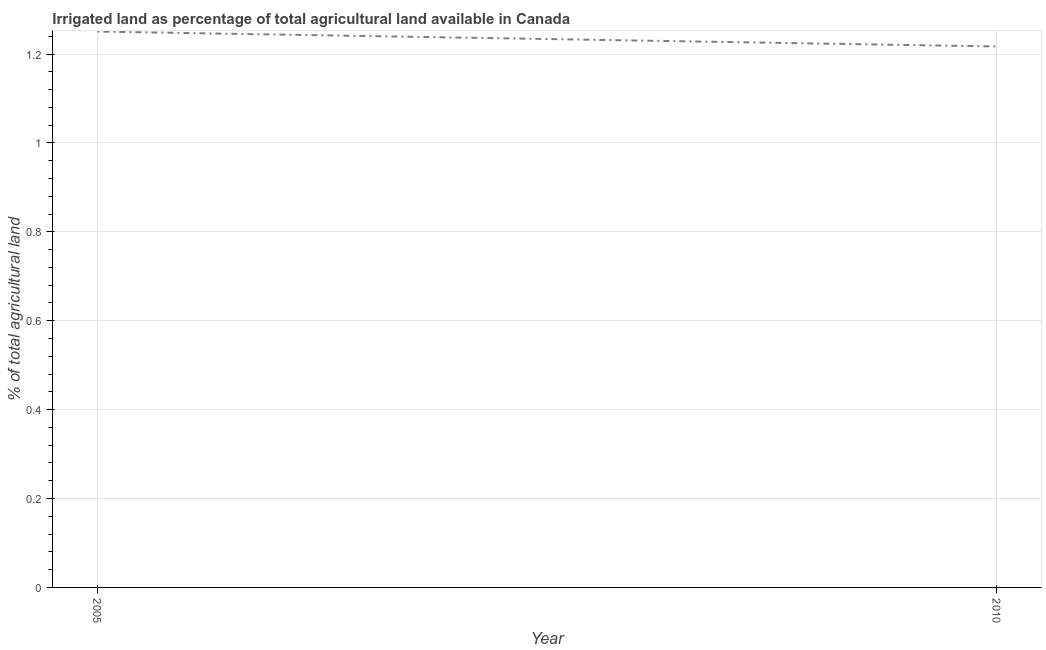What is the percentage of agricultural irrigated land in 2010?
Provide a short and direct response. 1.22. Across all years, what is the maximum percentage of agricultural irrigated land?
Make the answer very short. 1.25. Across all years, what is the minimum percentage of agricultural irrigated land?
Your response must be concise. 1.22. In which year was the percentage of agricultural irrigated land maximum?
Make the answer very short. 2005. In which year was the percentage of agricultural irrigated land minimum?
Keep it short and to the point. 2010. What is the sum of the percentage of agricultural irrigated land?
Give a very brief answer. 2.47. What is the difference between the percentage of agricultural irrigated land in 2005 and 2010?
Provide a succinct answer. 0.03. What is the average percentage of agricultural irrigated land per year?
Make the answer very short. 1.23. What is the median percentage of agricultural irrigated land?
Keep it short and to the point. 1.23. Do a majority of the years between 2010 and 2005 (inclusive) have percentage of agricultural irrigated land greater than 0.16 %?
Your answer should be very brief. No. What is the ratio of the percentage of agricultural irrigated land in 2005 to that in 2010?
Provide a short and direct response. 1.03. Is the percentage of agricultural irrigated land in 2005 less than that in 2010?
Offer a very short reply. No. In how many years, is the percentage of agricultural irrigated land greater than the average percentage of agricultural irrigated land taken over all years?
Give a very brief answer. 1. How many years are there in the graph?
Ensure brevity in your answer.  2. What is the difference between two consecutive major ticks on the Y-axis?
Offer a terse response. 0.2. Are the values on the major ticks of Y-axis written in scientific E-notation?
Provide a succinct answer. No. What is the title of the graph?
Your answer should be very brief. Irrigated land as percentage of total agricultural land available in Canada. What is the label or title of the X-axis?
Provide a succinct answer. Year. What is the label or title of the Y-axis?
Offer a terse response. % of total agricultural land. What is the % of total agricultural land of 2005?
Keep it short and to the point. 1.25. What is the % of total agricultural land in 2010?
Provide a short and direct response. 1.22. What is the difference between the % of total agricultural land in 2005 and 2010?
Your answer should be very brief. 0.03. What is the ratio of the % of total agricultural land in 2005 to that in 2010?
Provide a short and direct response. 1.03. 